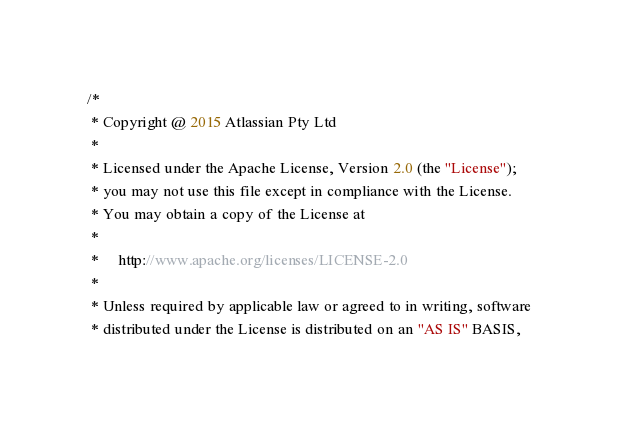Convert code to text. <code><loc_0><loc_0><loc_500><loc_500><_Java_>/*
 * Copyright @ 2015 Atlassian Pty Ltd
 *
 * Licensed under the Apache License, Version 2.0 (the "License");
 * you may not use this file except in compliance with the License.
 * You may obtain a copy of the License at
 *
 *     http://www.apache.org/licenses/LICENSE-2.0
 *
 * Unless required by applicable law or agreed to in writing, software
 * distributed under the License is distributed on an "AS IS" BASIS,</code> 